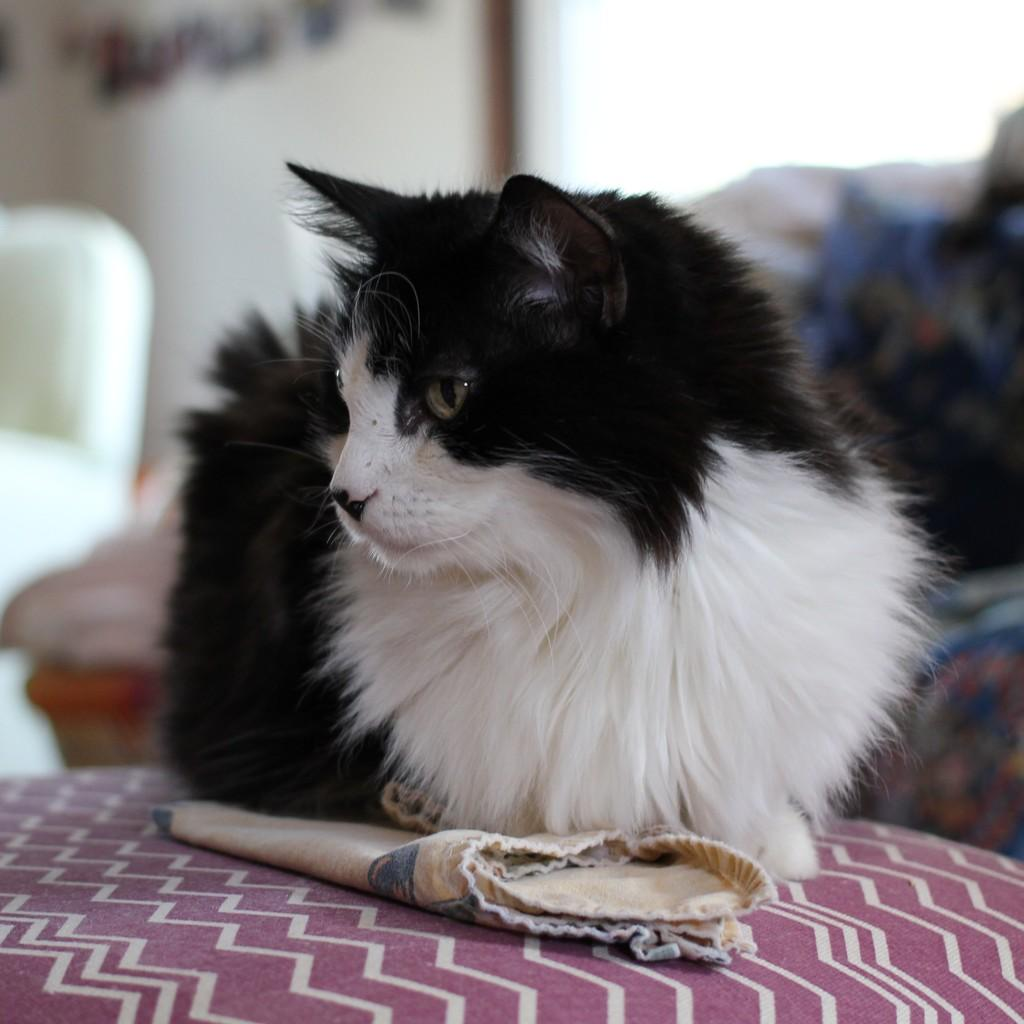What is the main subject in the center of the image? There is a cat in the center of the image. What is the cat resting on? The cat is on a surface. What is located near the cat? There is a cloth beside the cat. What can be seen in the background of the image? There is a sofa with cushions and a wall in the background. What type of feast is being prepared in the image? There is no indication of a feast or any food preparation in the image; it primarily features a cat and its surroundings. 